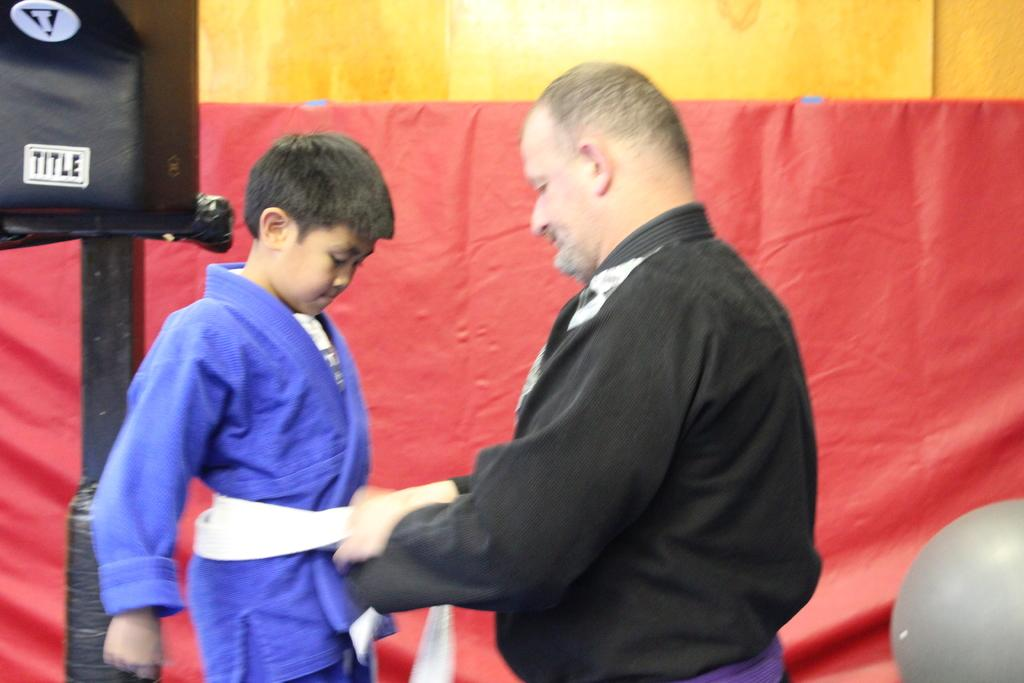Who are the people in the image? There is a man and a child in the image. What can be inferred about their relationship based on the image? The image does not provide enough information to determine their relationship. Can you describe the setting or environment in which the image takes place? The facts provided do not give any information about the setting or environment. What type of plants can be seen being cared for by the maid in the image? There is no maid or plants present in the image. 